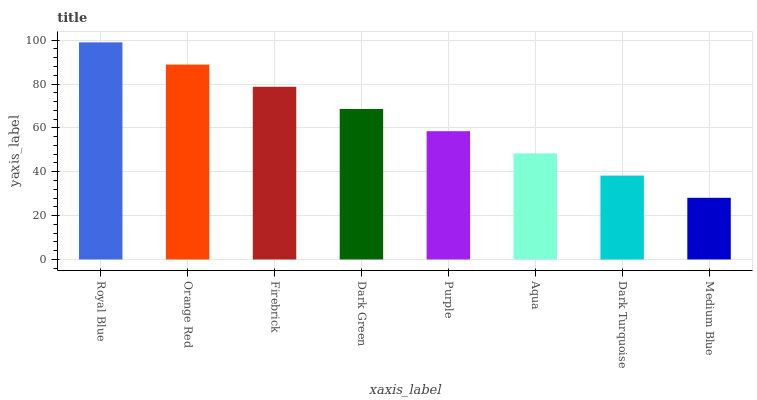Is Royal Blue the maximum?
Answer yes or no. Yes. Is Orange Red the minimum?
Answer yes or no. No. Is Orange Red the maximum?
Answer yes or no. No. Is Royal Blue greater than Orange Red?
Answer yes or no. Yes. Is Orange Red less than Royal Blue?
Answer yes or no. Yes. Is Orange Red greater than Royal Blue?
Answer yes or no. No. Is Royal Blue less than Orange Red?
Answer yes or no. No. Is Dark Green the high median?
Answer yes or no. Yes. Is Purple the low median?
Answer yes or no. Yes. Is Royal Blue the high median?
Answer yes or no. No. Is Firebrick the low median?
Answer yes or no. No. 